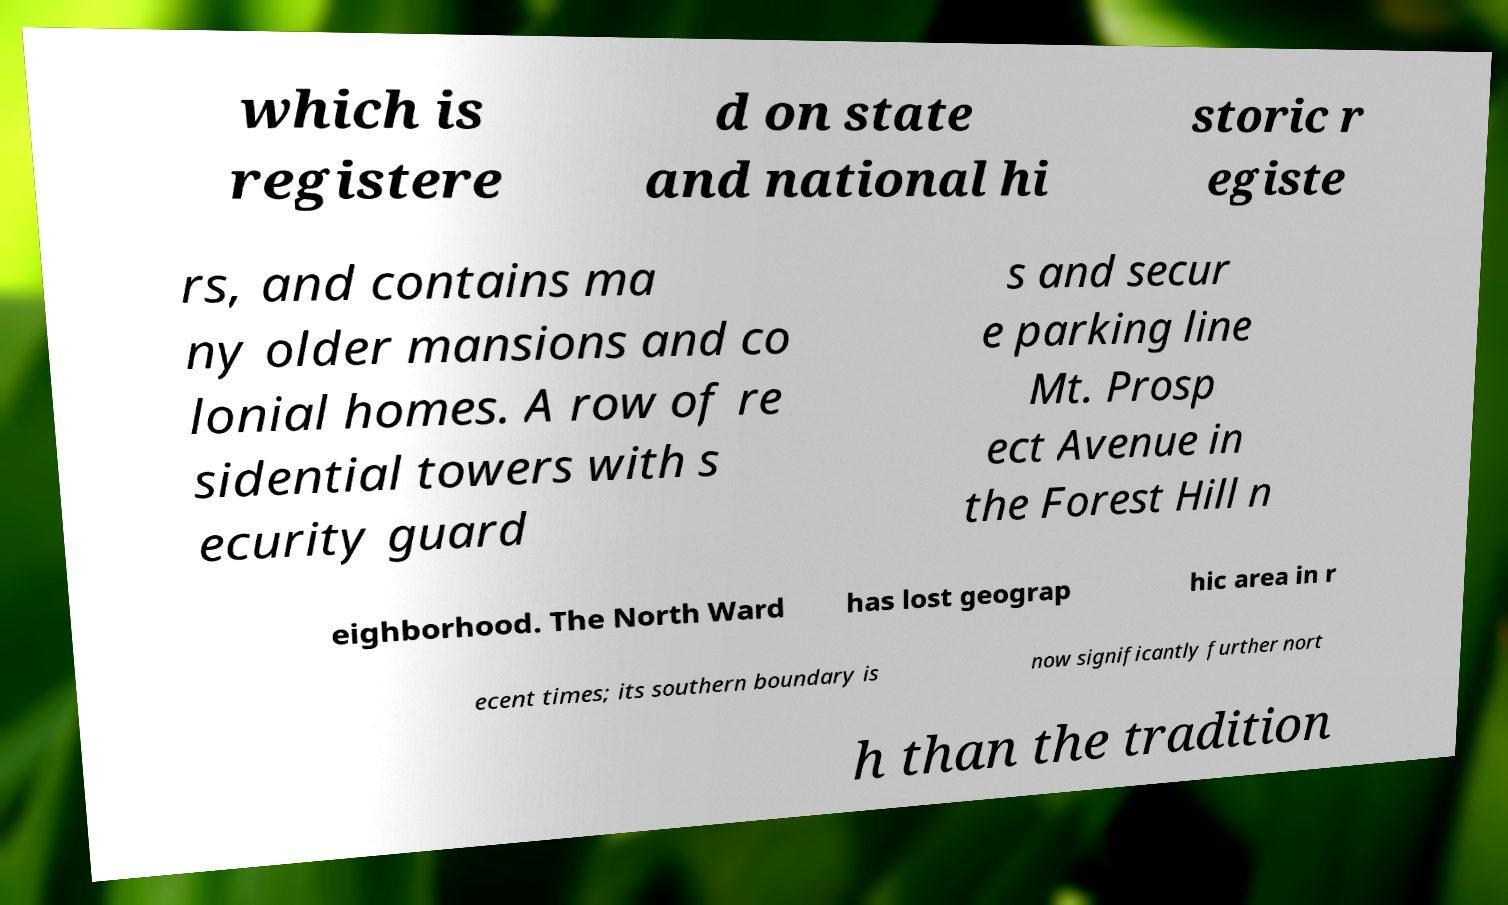Please identify and transcribe the text found in this image. which is registere d on state and national hi storic r egiste rs, and contains ma ny older mansions and co lonial homes. A row of re sidential towers with s ecurity guard s and secur e parking line Mt. Prosp ect Avenue in the Forest Hill n eighborhood. The North Ward has lost geograp hic area in r ecent times; its southern boundary is now significantly further nort h than the tradition 